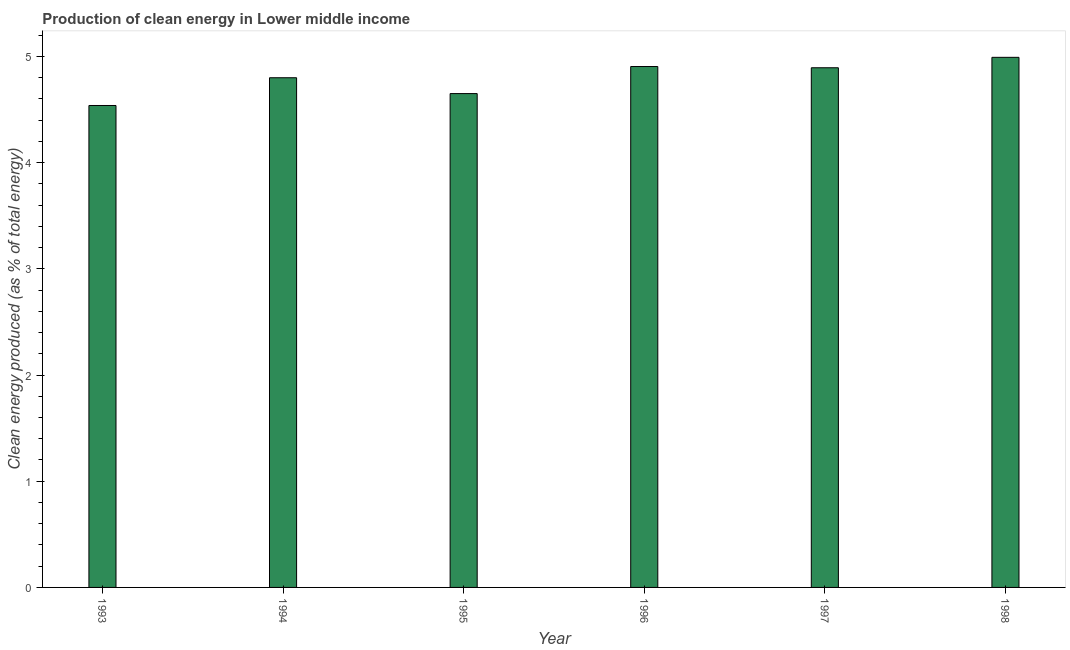What is the title of the graph?
Offer a terse response. Production of clean energy in Lower middle income. What is the label or title of the Y-axis?
Ensure brevity in your answer.  Clean energy produced (as % of total energy). What is the production of clean energy in 1995?
Your response must be concise. 4.65. Across all years, what is the maximum production of clean energy?
Provide a short and direct response. 4.99. Across all years, what is the minimum production of clean energy?
Your answer should be compact. 4.54. In which year was the production of clean energy minimum?
Ensure brevity in your answer.  1993. What is the sum of the production of clean energy?
Make the answer very short. 28.77. What is the difference between the production of clean energy in 1995 and 1997?
Provide a short and direct response. -0.24. What is the average production of clean energy per year?
Make the answer very short. 4.8. What is the median production of clean energy?
Provide a succinct answer. 4.85. Do a majority of the years between 1998 and 1996 (inclusive) have production of clean energy greater than 2.2 %?
Make the answer very short. Yes. What is the ratio of the production of clean energy in 1993 to that in 1998?
Your answer should be compact. 0.91. Is the production of clean energy in 1996 less than that in 1998?
Provide a short and direct response. Yes. What is the difference between the highest and the second highest production of clean energy?
Keep it short and to the point. 0.09. Is the sum of the production of clean energy in 1993 and 1997 greater than the maximum production of clean energy across all years?
Offer a terse response. Yes. What is the difference between the highest and the lowest production of clean energy?
Your answer should be very brief. 0.45. In how many years, is the production of clean energy greater than the average production of clean energy taken over all years?
Provide a short and direct response. 4. How many bars are there?
Give a very brief answer. 6. Are all the bars in the graph horizontal?
Offer a terse response. No. How many years are there in the graph?
Provide a short and direct response. 6. What is the difference between two consecutive major ticks on the Y-axis?
Your response must be concise. 1. What is the Clean energy produced (as % of total energy) in 1993?
Keep it short and to the point. 4.54. What is the Clean energy produced (as % of total energy) in 1994?
Provide a short and direct response. 4.8. What is the Clean energy produced (as % of total energy) in 1995?
Provide a succinct answer. 4.65. What is the Clean energy produced (as % of total energy) of 1996?
Offer a very short reply. 4.9. What is the Clean energy produced (as % of total energy) in 1997?
Keep it short and to the point. 4.89. What is the Clean energy produced (as % of total energy) of 1998?
Give a very brief answer. 4.99. What is the difference between the Clean energy produced (as % of total energy) in 1993 and 1994?
Make the answer very short. -0.26. What is the difference between the Clean energy produced (as % of total energy) in 1993 and 1995?
Keep it short and to the point. -0.11. What is the difference between the Clean energy produced (as % of total energy) in 1993 and 1996?
Your answer should be very brief. -0.37. What is the difference between the Clean energy produced (as % of total energy) in 1993 and 1997?
Provide a succinct answer. -0.36. What is the difference between the Clean energy produced (as % of total energy) in 1993 and 1998?
Ensure brevity in your answer.  -0.45. What is the difference between the Clean energy produced (as % of total energy) in 1994 and 1995?
Your response must be concise. 0.15. What is the difference between the Clean energy produced (as % of total energy) in 1994 and 1996?
Keep it short and to the point. -0.11. What is the difference between the Clean energy produced (as % of total energy) in 1994 and 1997?
Your response must be concise. -0.09. What is the difference between the Clean energy produced (as % of total energy) in 1994 and 1998?
Make the answer very short. -0.19. What is the difference between the Clean energy produced (as % of total energy) in 1995 and 1996?
Your answer should be very brief. -0.25. What is the difference between the Clean energy produced (as % of total energy) in 1995 and 1997?
Make the answer very short. -0.24. What is the difference between the Clean energy produced (as % of total energy) in 1995 and 1998?
Give a very brief answer. -0.34. What is the difference between the Clean energy produced (as % of total energy) in 1996 and 1997?
Offer a very short reply. 0.01. What is the difference between the Clean energy produced (as % of total energy) in 1996 and 1998?
Ensure brevity in your answer.  -0.09. What is the difference between the Clean energy produced (as % of total energy) in 1997 and 1998?
Keep it short and to the point. -0.1. What is the ratio of the Clean energy produced (as % of total energy) in 1993 to that in 1994?
Give a very brief answer. 0.95. What is the ratio of the Clean energy produced (as % of total energy) in 1993 to that in 1995?
Your response must be concise. 0.98. What is the ratio of the Clean energy produced (as % of total energy) in 1993 to that in 1996?
Ensure brevity in your answer.  0.93. What is the ratio of the Clean energy produced (as % of total energy) in 1993 to that in 1997?
Make the answer very short. 0.93. What is the ratio of the Clean energy produced (as % of total energy) in 1993 to that in 1998?
Your answer should be compact. 0.91. What is the ratio of the Clean energy produced (as % of total energy) in 1994 to that in 1995?
Your response must be concise. 1.03. What is the ratio of the Clean energy produced (as % of total energy) in 1994 to that in 1996?
Provide a succinct answer. 0.98. What is the ratio of the Clean energy produced (as % of total energy) in 1994 to that in 1997?
Ensure brevity in your answer.  0.98. What is the ratio of the Clean energy produced (as % of total energy) in 1995 to that in 1996?
Offer a terse response. 0.95. What is the ratio of the Clean energy produced (as % of total energy) in 1995 to that in 1997?
Offer a terse response. 0.95. What is the ratio of the Clean energy produced (as % of total energy) in 1995 to that in 1998?
Keep it short and to the point. 0.93. What is the ratio of the Clean energy produced (as % of total energy) in 1996 to that in 1997?
Provide a short and direct response. 1. What is the ratio of the Clean energy produced (as % of total energy) in 1997 to that in 1998?
Your answer should be very brief. 0.98. 